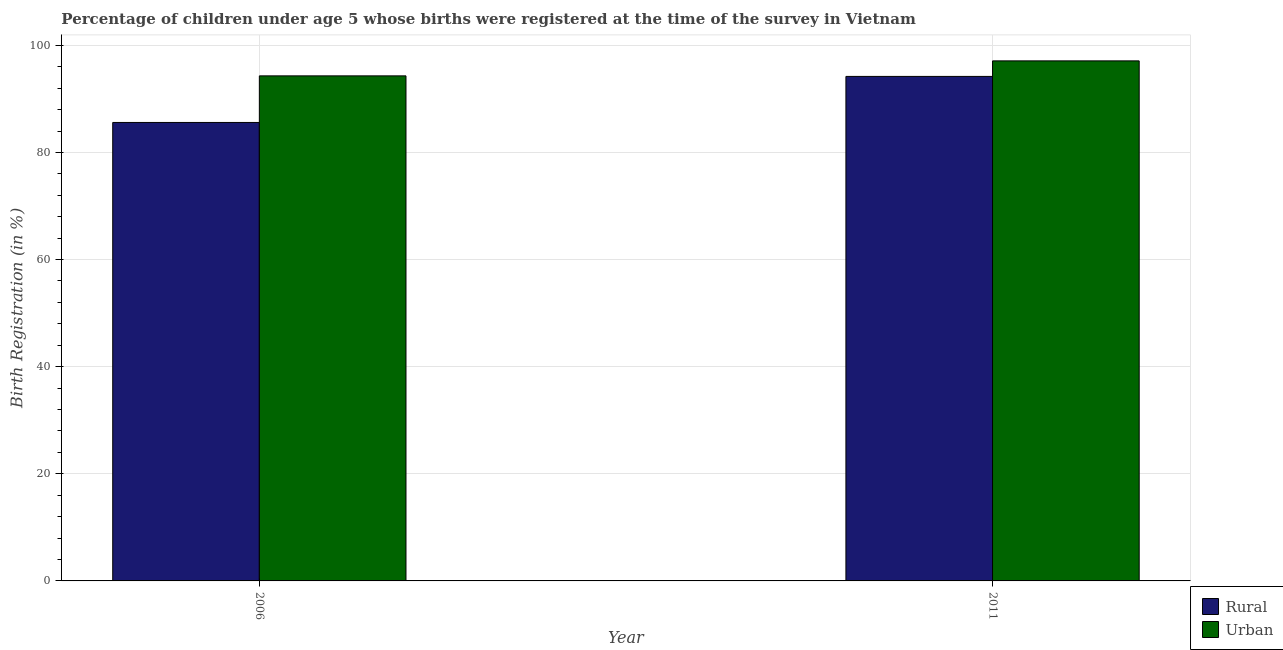How many different coloured bars are there?
Your answer should be very brief. 2. How many groups of bars are there?
Ensure brevity in your answer.  2. Are the number of bars on each tick of the X-axis equal?
Ensure brevity in your answer.  Yes. How many bars are there on the 1st tick from the left?
Give a very brief answer. 2. What is the rural birth registration in 2006?
Give a very brief answer. 85.6. Across all years, what is the maximum rural birth registration?
Ensure brevity in your answer.  94.2. Across all years, what is the minimum urban birth registration?
Ensure brevity in your answer.  94.3. In which year was the rural birth registration maximum?
Your answer should be compact. 2011. In which year was the urban birth registration minimum?
Make the answer very short. 2006. What is the total rural birth registration in the graph?
Your answer should be compact. 179.8. What is the difference between the rural birth registration in 2006 and that in 2011?
Provide a short and direct response. -8.6. What is the difference between the rural birth registration in 2011 and the urban birth registration in 2006?
Offer a very short reply. 8.6. What is the average rural birth registration per year?
Offer a terse response. 89.9. In the year 2011, what is the difference between the urban birth registration and rural birth registration?
Offer a terse response. 0. What is the ratio of the rural birth registration in 2006 to that in 2011?
Make the answer very short. 0.91. Is the urban birth registration in 2006 less than that in 2011?
Your response must be concise. Yes. In how many years, is the urban birth registration greater than the average urban birth registration taken over all years?
Your answer should be compact. 1. What does the 1st bar from the left in 2006 represents?
Your answer should be compact. Rural. What does the 2nd bar from the right in 2011 represents?
Your answer should be compact. Rural. What is the difference between two consecutive major ticks on the Y-axis?
Offer a very short reply. 20. Are the values on the major ticks of Y-axis written in scientific E-notation?
Your response must be concise. No. Does the graph contain any zero values?
Ensure brevity in your answer.  No. Does the graph contain grids?
Your answer should be very brief. Yes. How are the legend labels stacked?
Keep it short and to the point. Vertical. What is the title of the graph?
Your answer should be very brief. Percentage of children under age 5 whose births were registered at the time of the survey in Vietnam. What is the label or title of the Y-axis?
Keep it short and to the point. Birth Registration (in %). What is the Birth Registration (in %) in Rural in 2006?
Make the answer very short. 85.6. What is the Birth Registration (in %) in Urban in 2006?
Ensure brevity in your answer.  94.3. What is the Birth Registration (in %) of Rural in 2011?
Your response must be concise. 94.2. What is the Birth Registration (in %) in Urban in 2011?
Ensure brevity in your answer.  97.1. Across all years, what is the maximum Birth Registration (in %) of Rural?
Make the answer very short. 94.2. Across all years, what is the maximum Birth Registration (in %) in Urban?
Your response must be concise. 97.1. Across all years, what is the minimum Birth Registration (in %) in Rural?
Provide a short and direct response. 85.6. Across all years, what is the minimum Birth Registration (in %) in Urban?
Offer a terse response. 94.3. What is the total Birth Registration (in %) of Rural in the graph?
Your response must be concise. 179.8. What is the total Birth Registration (in %) in Urban in the graph?
Your response must be concise. 191.4. What is the difference between the Birth Registration (in %) of Rural in 2006 and that in 2011?
Your answer should be very brief. -8.6. What is the difference between the Birth Registration (in %) in Rural in 2006 and the Birth Registration (in %) in Urban in 2011?
Make the answer very short. -11.5. What is the average Birth Registration (in %) of Rural per year?
Provide a short and direct response. 89.9. What is the average Birth Registration (in %) of Urban per year?
Keep it short and to the point. 95.7. What is the ratio of the Birth Registration (in %) of Rural in 2006 to that in 2011?
Offer a very short reply. 0.91. What is the ratio of the Birth Registration (in %) in Urban in 2006 to that in 2011?
Give a very brief answer. 0.97. What is the difference between the highest and the second highest Birth Registration (in %) of Urban?
Make the answer very short. 2.8. 